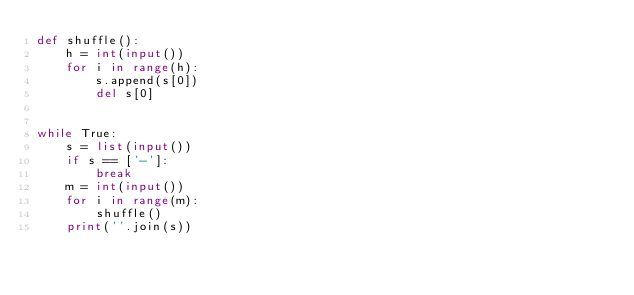Convert code to text. <code><loc_0><loc_0><loc_500><loc_500><_Python_>def shuffle():
    h = int(input())
    for i in range(h):
        s.append(s[0])
        del s[0]


while True:
    s = list(input())
    if s == ['-']:
        break
    m = int(input())
    for i in range(m):
        shuffle()
    print(''.join(s))
</code> 